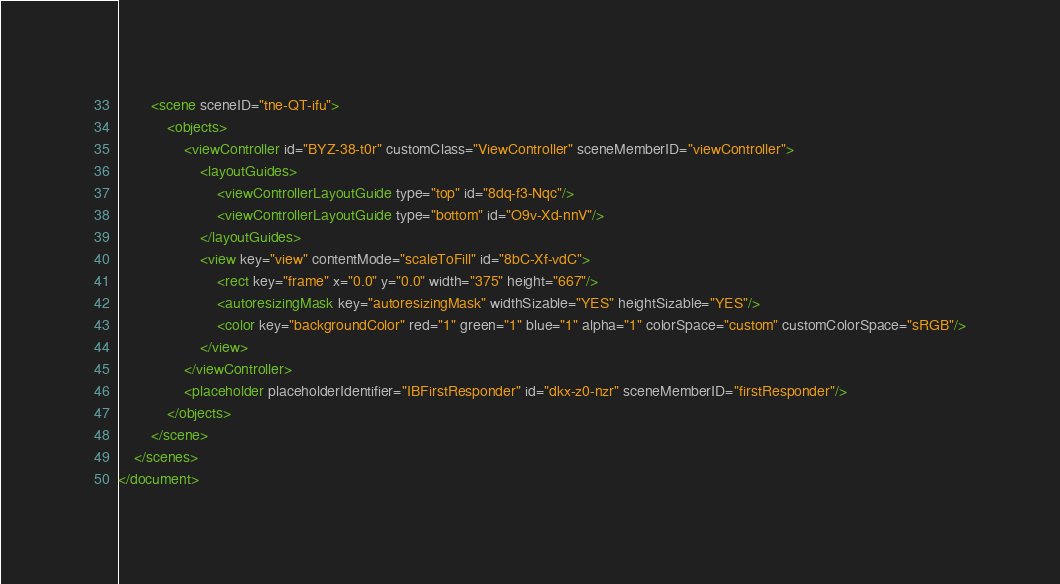<code> <loc_0><loc_0><loc_500><loc_500><_XML_>        <scene sceneID="tne-QT-ifu">
            <objects>
                <viewController id="BYZ-38-t0r" customClass="ViewController" sceneMemberID="viewController">
                    <layoutGuides>
                        <viewControllerLayoutGuide type="top" id="8dq-f3-Nqc"/>
                        <viewControllerLayoutGuide type="bottom" id="O9v-Xd-nnV"/>
                    </layoutGuides>
                    <view key="view" contentMode="scaleToFill" id="8bC-Xf-vdC">
                        <rect key="frame" x="0.0" y="0.0" width="375" height="667"/>
                        <autoresizingMask key="autoresizingMask" widthSizable="YES" heightSizable="YES"/>
                        <color key="backgroundColor" red="1" green="1" blue="1" alpha="1" colorSpace="custom" customColorSpace="sRGB"/>
                    </view>
                </viewController>
                <placeholder placeholderIdentifier="IBFirstResponder" id="dkx-z0-nzr" sceneMemberID="firstResponder"/>
            </objects>
        </scene>
    </scenes>
</document>
</code> 